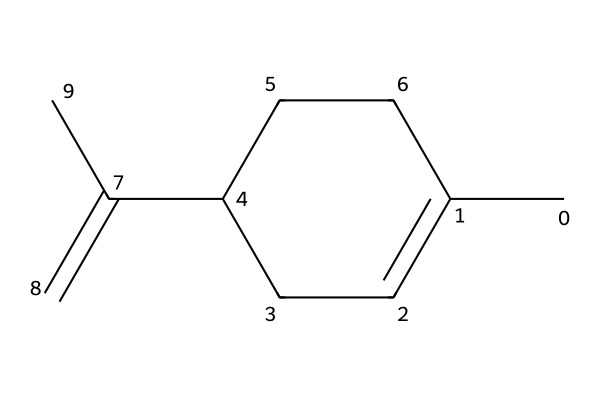What is the name of this compound? The SMILES representation indicates the compound is limonene, which is known for its presence in citrus fruits. The specific arrangement of atoms and bonds suggests that it is a cyclic monoterpene.
Answer: limonene How many carbon atoms are in limonene? By analyzing the SMILES string, we can count the carbon atoms represented. The structure contains a total of 10 carbon atoms.
Answer: 10 What type of chemical structure does limonene have? The cyclic nature of the compound structure, along with its presence of double bonds, indicates that limonene has a cyclic aliphatic structure, as it consists of a ring and multiple bonds.
Answer: cyclic aliphatic How many double bonds are present in limonene? Reviewing the SMILES string shows that there are 2 double bonds in the molecular structure, represented by the 'C=C' and the connections around the ring.
Answer: 2 Is limonene saturated or unsaturated? The presence of double bonds in the structure indicates that limonene is not fully saturated with hydrogen atoms, categorizing it as an unsaturated compound.
Answer: unsaturated 